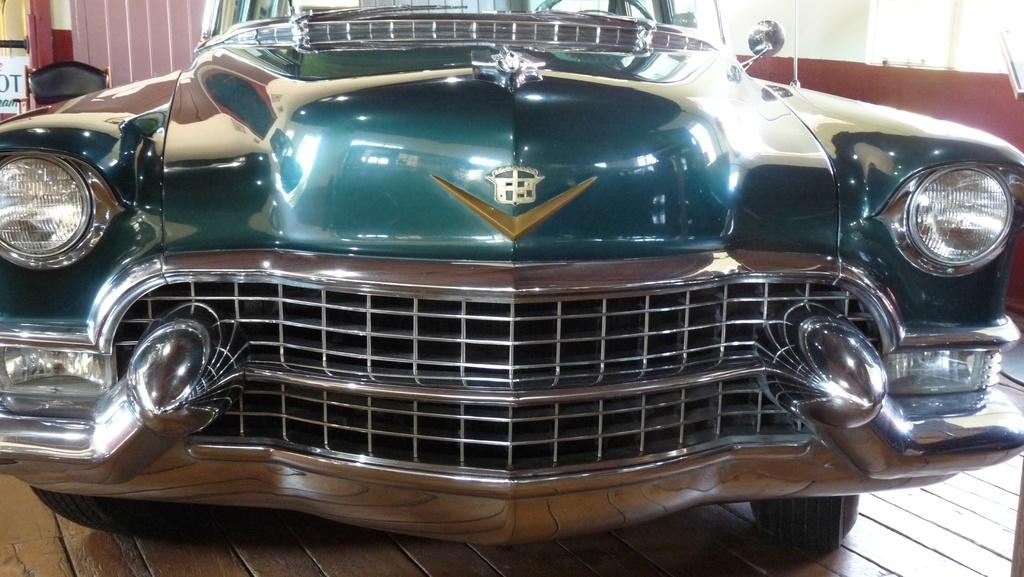What is the main subject of the image? The main subject of the image is a car. Can you describe the perspective of the image? The view of the car is close. What type of throat surgery is being performed on the car in the image? There is no indication of any surgery or medical procedure being performed on the car in the image. 